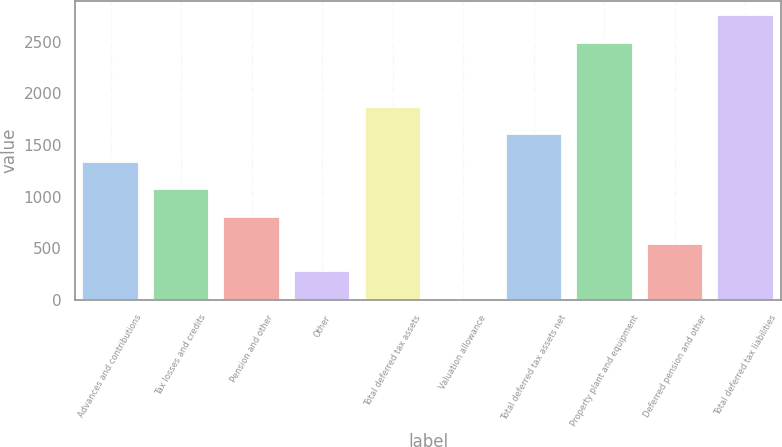Convert chart. <chart><loc_0><loc_0><loc_500><loc_500><bar_chart><fcel>Advances and contributions<fcel>Tax losses and credits<fcel>Pension and other<fcel>Other<fcel>Total deferred tax assets<fcel>Valuation allowance<fcel>Total deferred tax assets net<fcel>Property plant and equipment<fcel>Deferred pension and other<fcel>Total deferred tax liabilities<nl><fcel>1337<fcel>1072.2<fcel>807.4<fcel>277.8<fcel>1866.6<fcel>13<fcel>1601.8<fcel>2489<fcel>542.6<fcel>2753.8<nl></chart> 